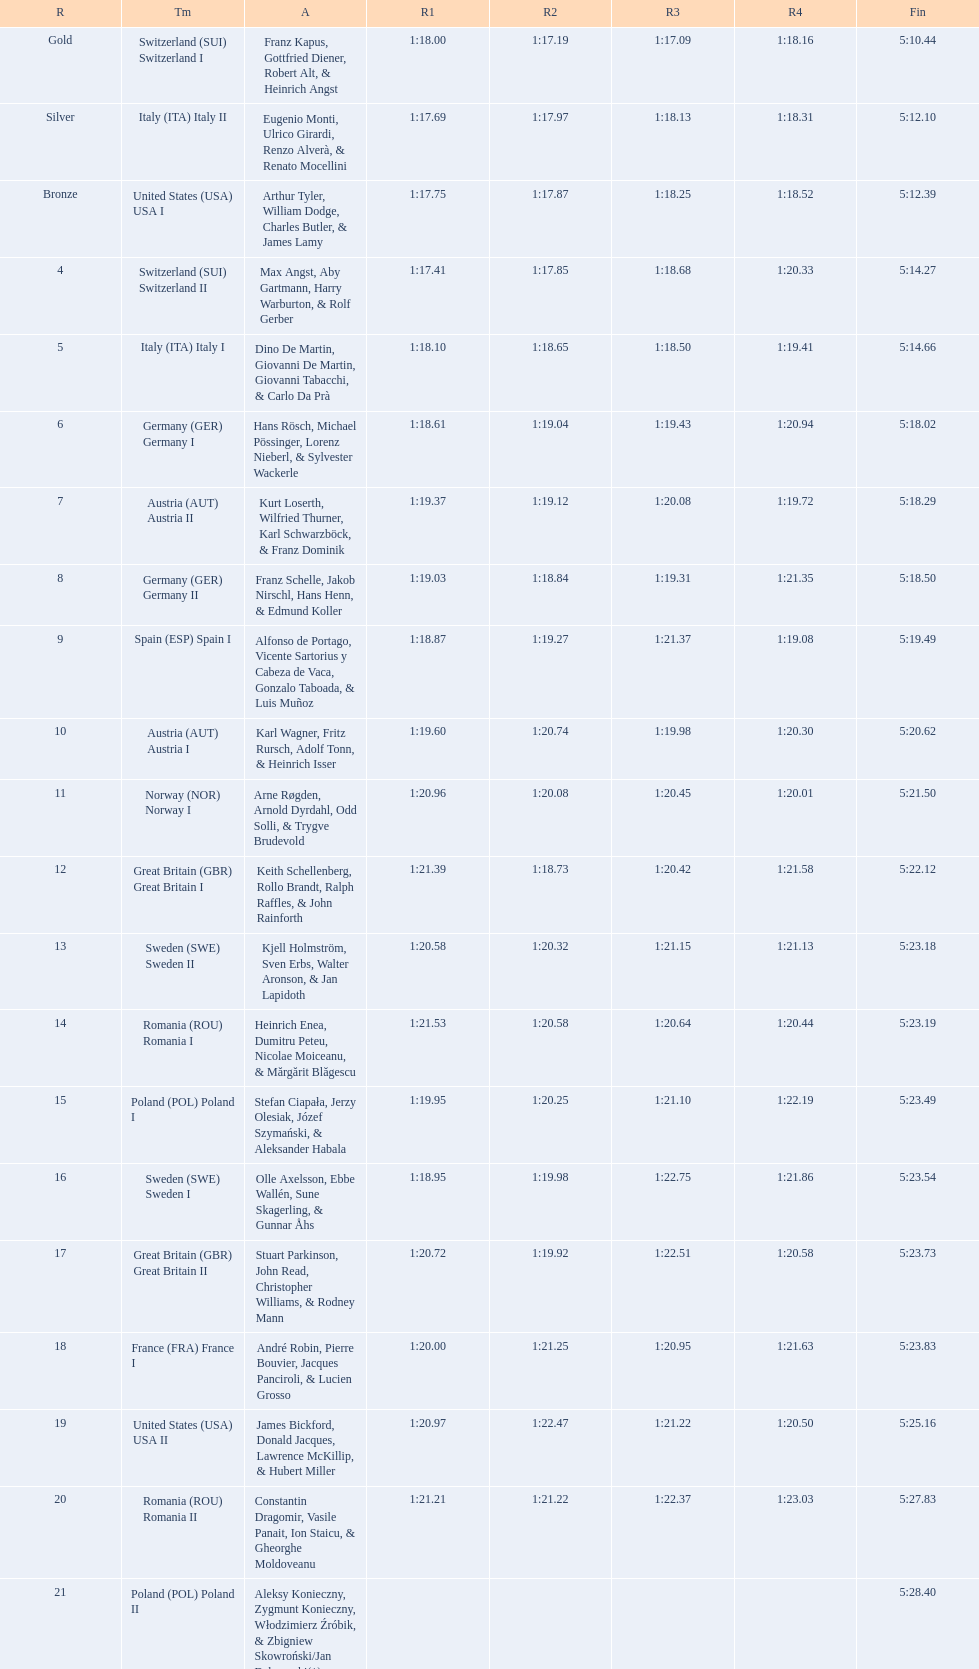Who is the previous team to italy (ita) italy ii? Switzerland (SUI) Switzerland I. 